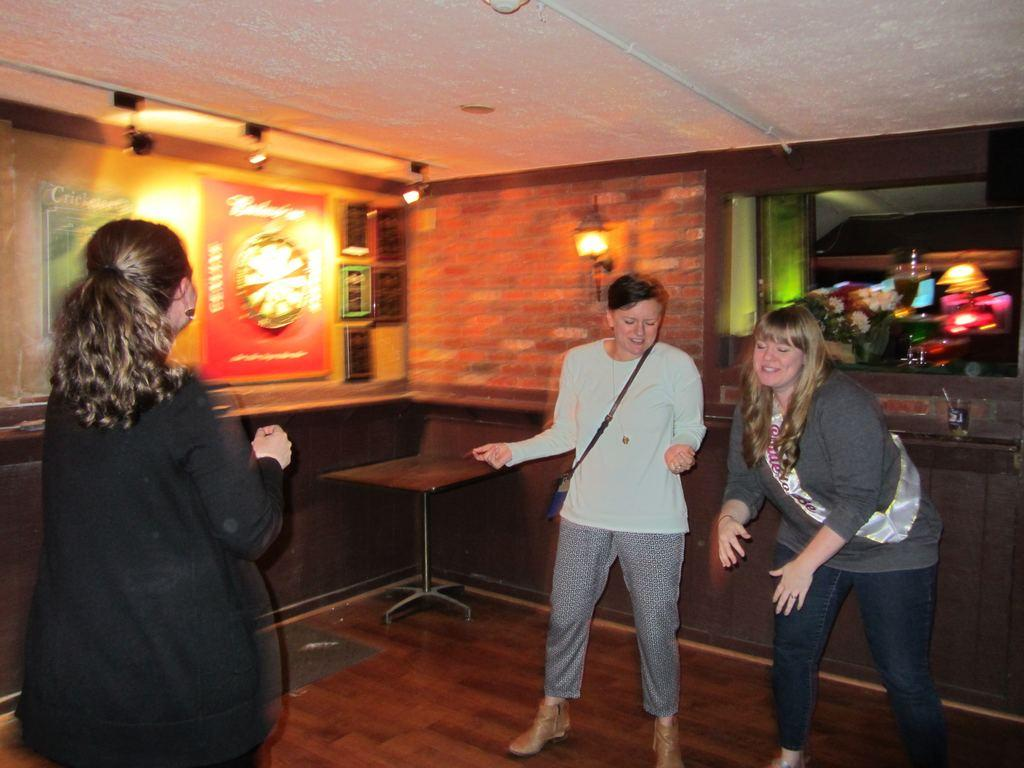What is the primary subject of the image? The primary subject of the image is women standing. Where are the women standing in the image? The women are standing on the floor in the image. What can be seen on the wall in the image? There are posters on the wall in the image. What shape is the mouth of the woman in the image? There is no specific woman mentioned in the image, and no mouths are visible in the image. 